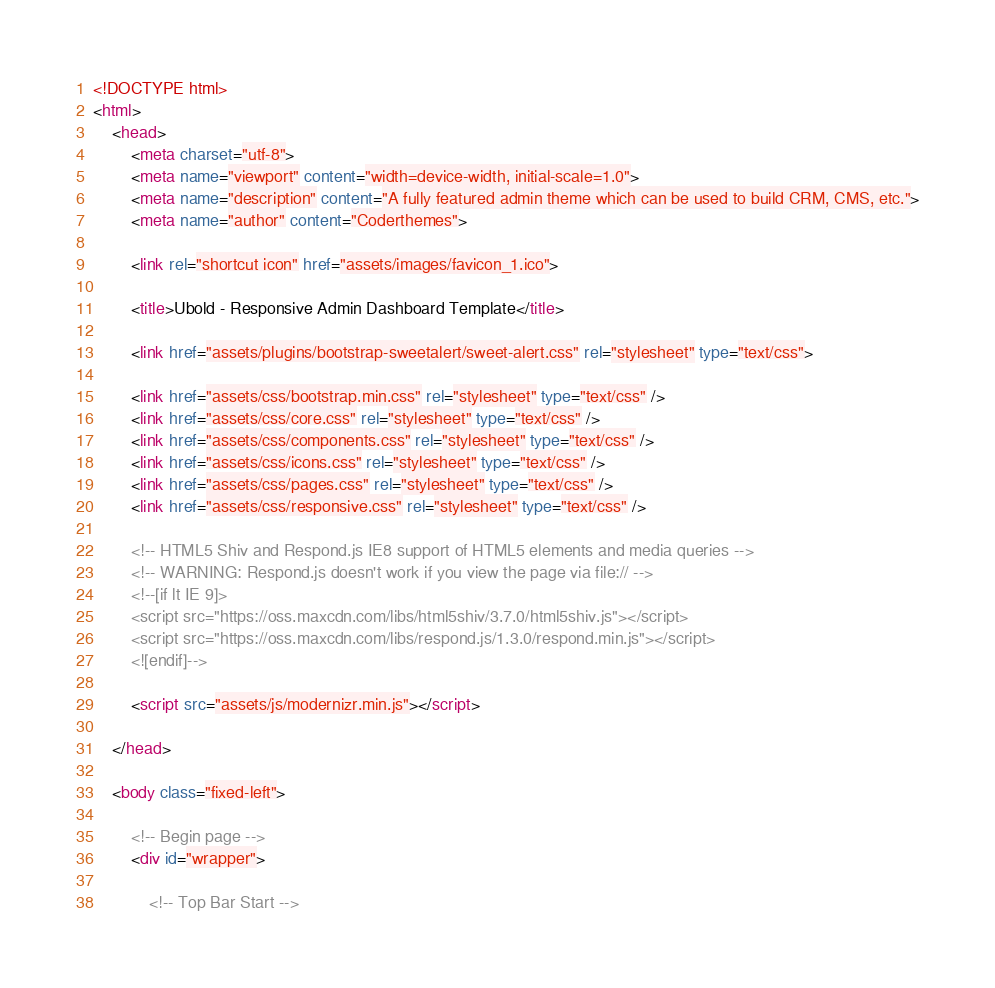<code> <loc_0><loc_0><loc_500><loc_500><_HTML_><!DOCTYPE html>
<html>
	<head>
		<meta charset="utf-8">
		<meta name="viewport" content="width=device-width, initial-scale=1.0">
		<meta name="description" content="A fully featured admin theme which can be used to build CRM, CMS, etc.">
		<meta name="author" content="Coderthemes">

		<link rel="shortcut icon" href="assets/images/favicon_1.ico">

		<title>Ubold - Responsive Admin Dashboard Template</title>
		
		<link href="assets/plugins/bootstrap-sweetalert/sweet-alert.css" rel="stylesheet" type="text/css">

		<link href="assets/css/bootstrap.min.css" rel="stylesheet" type="text/css" />
        <link href="assets/css/core.css" rel="stylesheet" type="text/css" />
        <link href="assets/css/components.css" rel="stylesheet" type="text/css" />
        <link href="assets/css/icons.css" rel="stylesheet" type="text/css" />
        <link href="assets/css/pages.css" rel="stylesheet" type="text/css" />
        <link href="assets/css/responsive.css" rel="stylesheet" type="text/css" />

        <!-- HTML5 Shiv and Respond.js IE8 support of HTML5 elements and media queries -->
        <!-- WARNING: Respond.js doesn't work if you view the page via file:// -->
        <!--[if lt IE 9]>
        <script src="https://oss.maxcdn.com/libs/html5shiv/3.7.0/html5shiv.js"></script>
        <script src="https://oss.maxcdn.com/libs/respond.js/1.3.0/respond.min.js"></script>
        <![endif]-->

        <script src="assets/js/modernizr.min.js"></script>

	</head>

	<body class="fixed-left">

		<!-- Begin page -->
		<div id="wrapper">

            <!-- Top Bar Start --></code> 